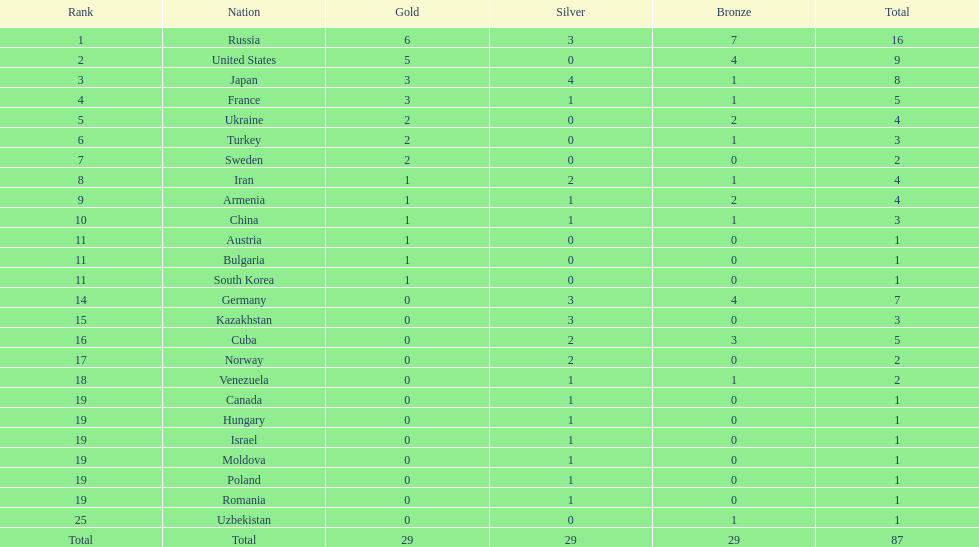What is the total number of gold medals won by japan and france together? 6. 